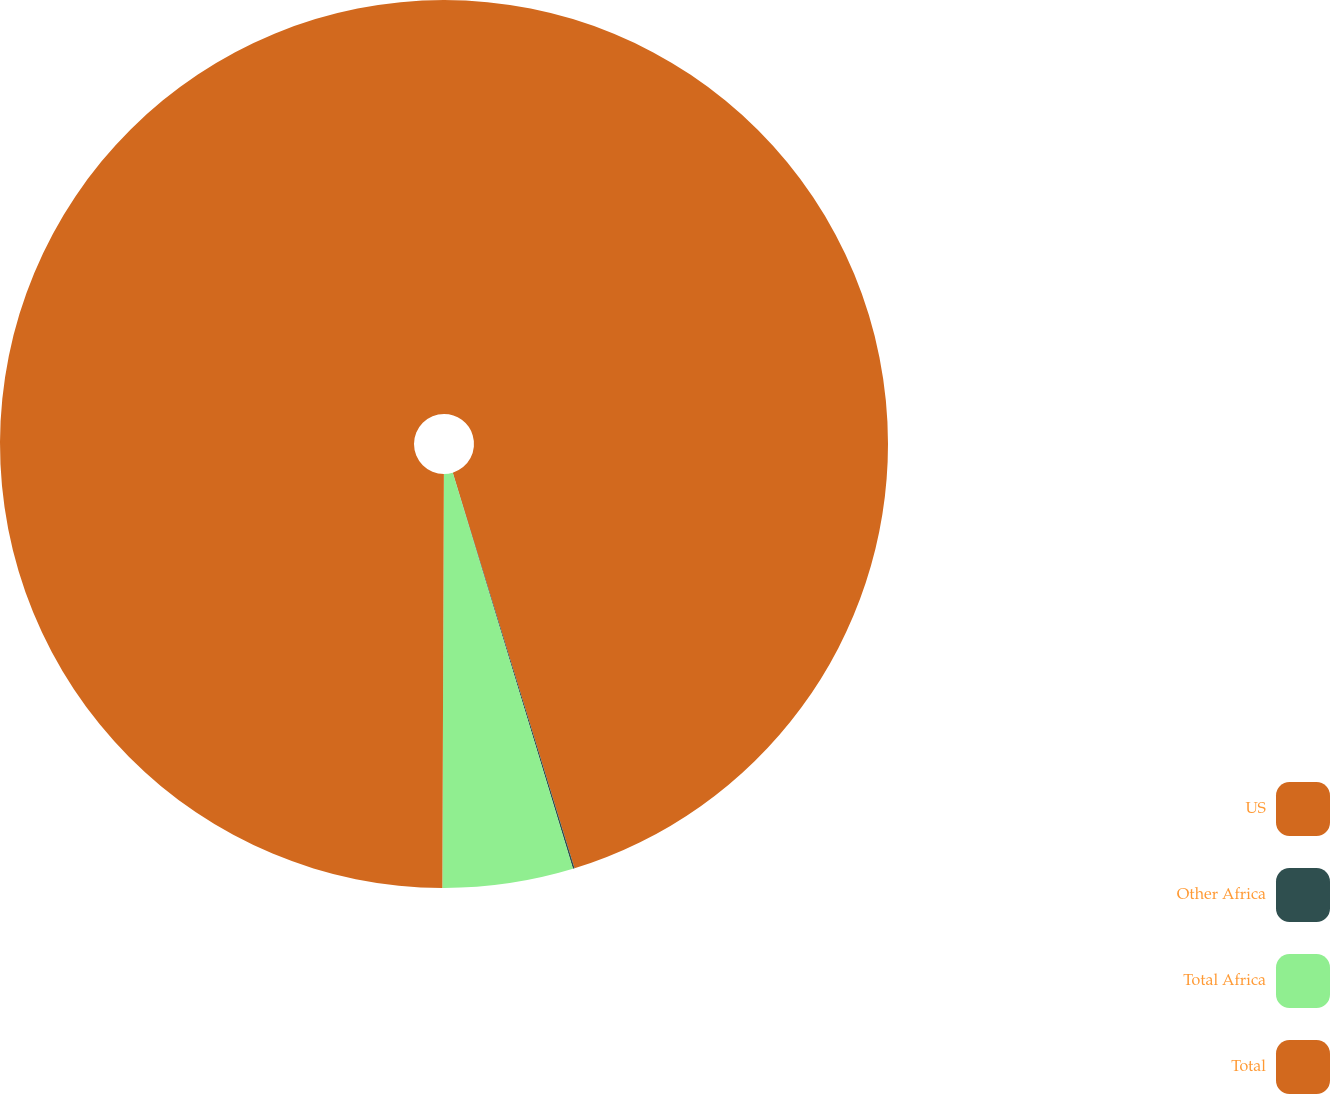Convert chart. <chart><loc_0><loc_0><loc_500><loc_500><pie_chart><fcel>US<fcel>Other Africa<fcel>Total Africa<fcel>Total<nl><fcel>45.25%<fcel>0.06%<fcel>4.75%<fcel>49.94%<nl></chart> 